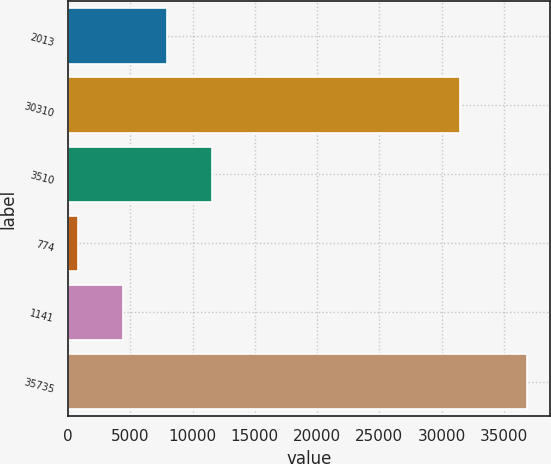Convert chart to OTSL. <chart><loc_0><loc_0><loc_500><loc_500><bar_chart><fcel>2013<fcel>30310<fcel>3510<fcel>774<fcel>1141<fcel>35735<nl><fcel>7978.6<fcel>31472<fcel>11590.9<fcel>754<fcel>4366.3<fcel>36877<nl></chart> 